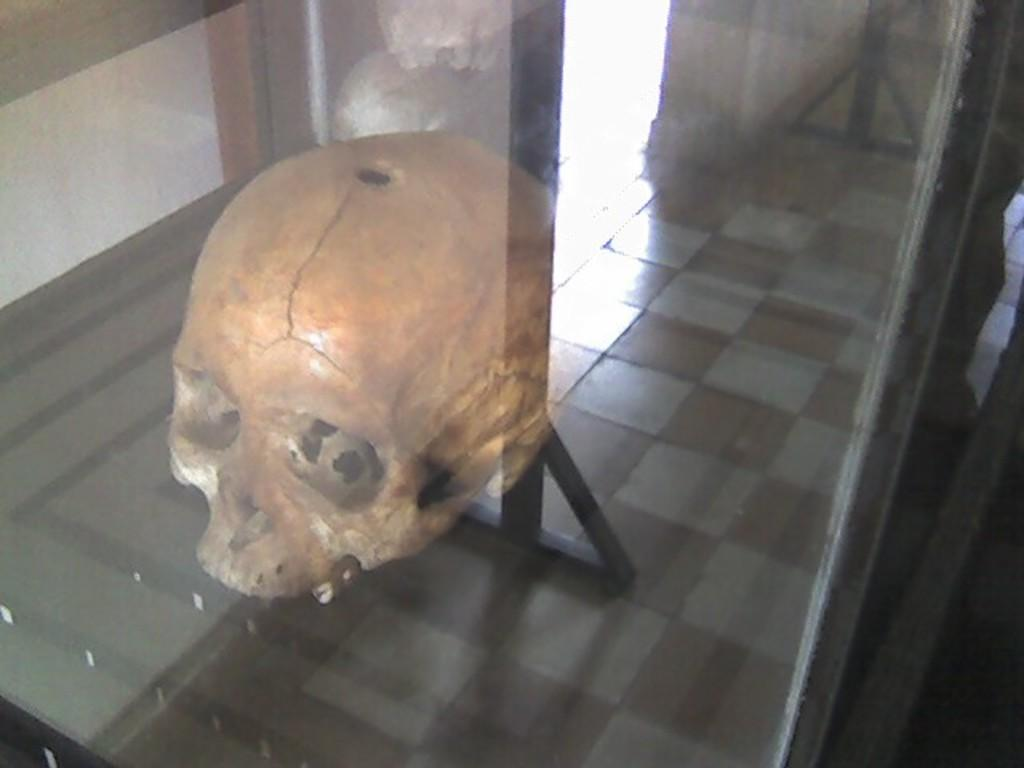What object contains a skull in the image? There is a skull inside a glass in the image. What is the flooring material in the room? The floor of the room is made up of tiles. What type of monkey can be seen climbing the skull in the image? There is no monkey present in the image, and the skull is inside a glass. What type of material is the skull made of in the image? The facts provided do not specify the material of the skull; it is only mentioned that there is a skull inside a glass. 